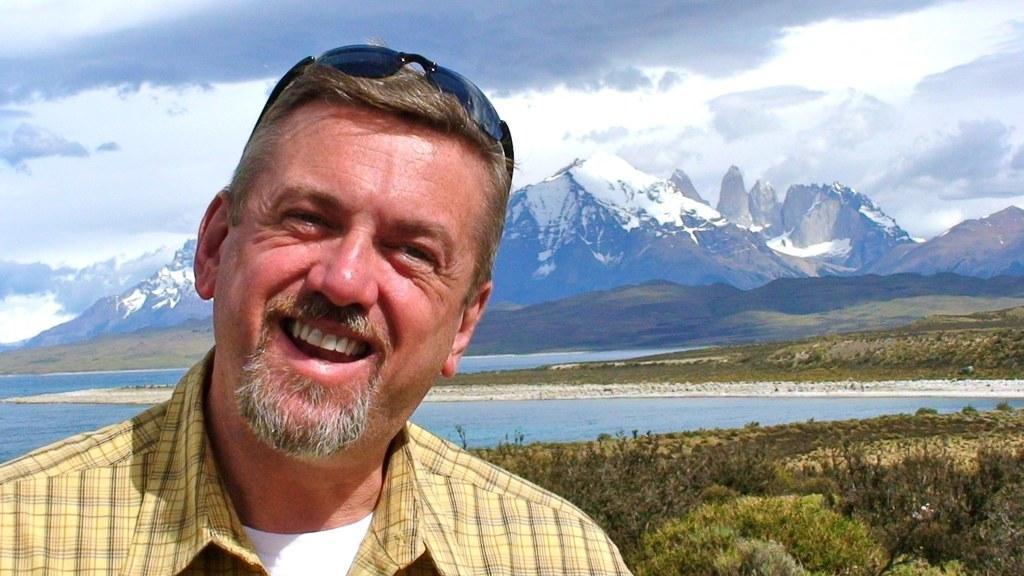Can you describe this image briefly? In this image in the left a person wearing yellow t-shirt is smiling. There is sunglasses on his head. In the background there is water body, hills, plants. The sky is cloudy. 